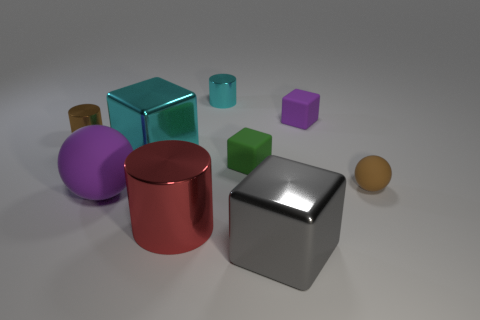Which object appears to be the largest based on this perspective? The silver cube in the foreground seems to be the largest object, given its prominence and relative size compared to the other shapes. 